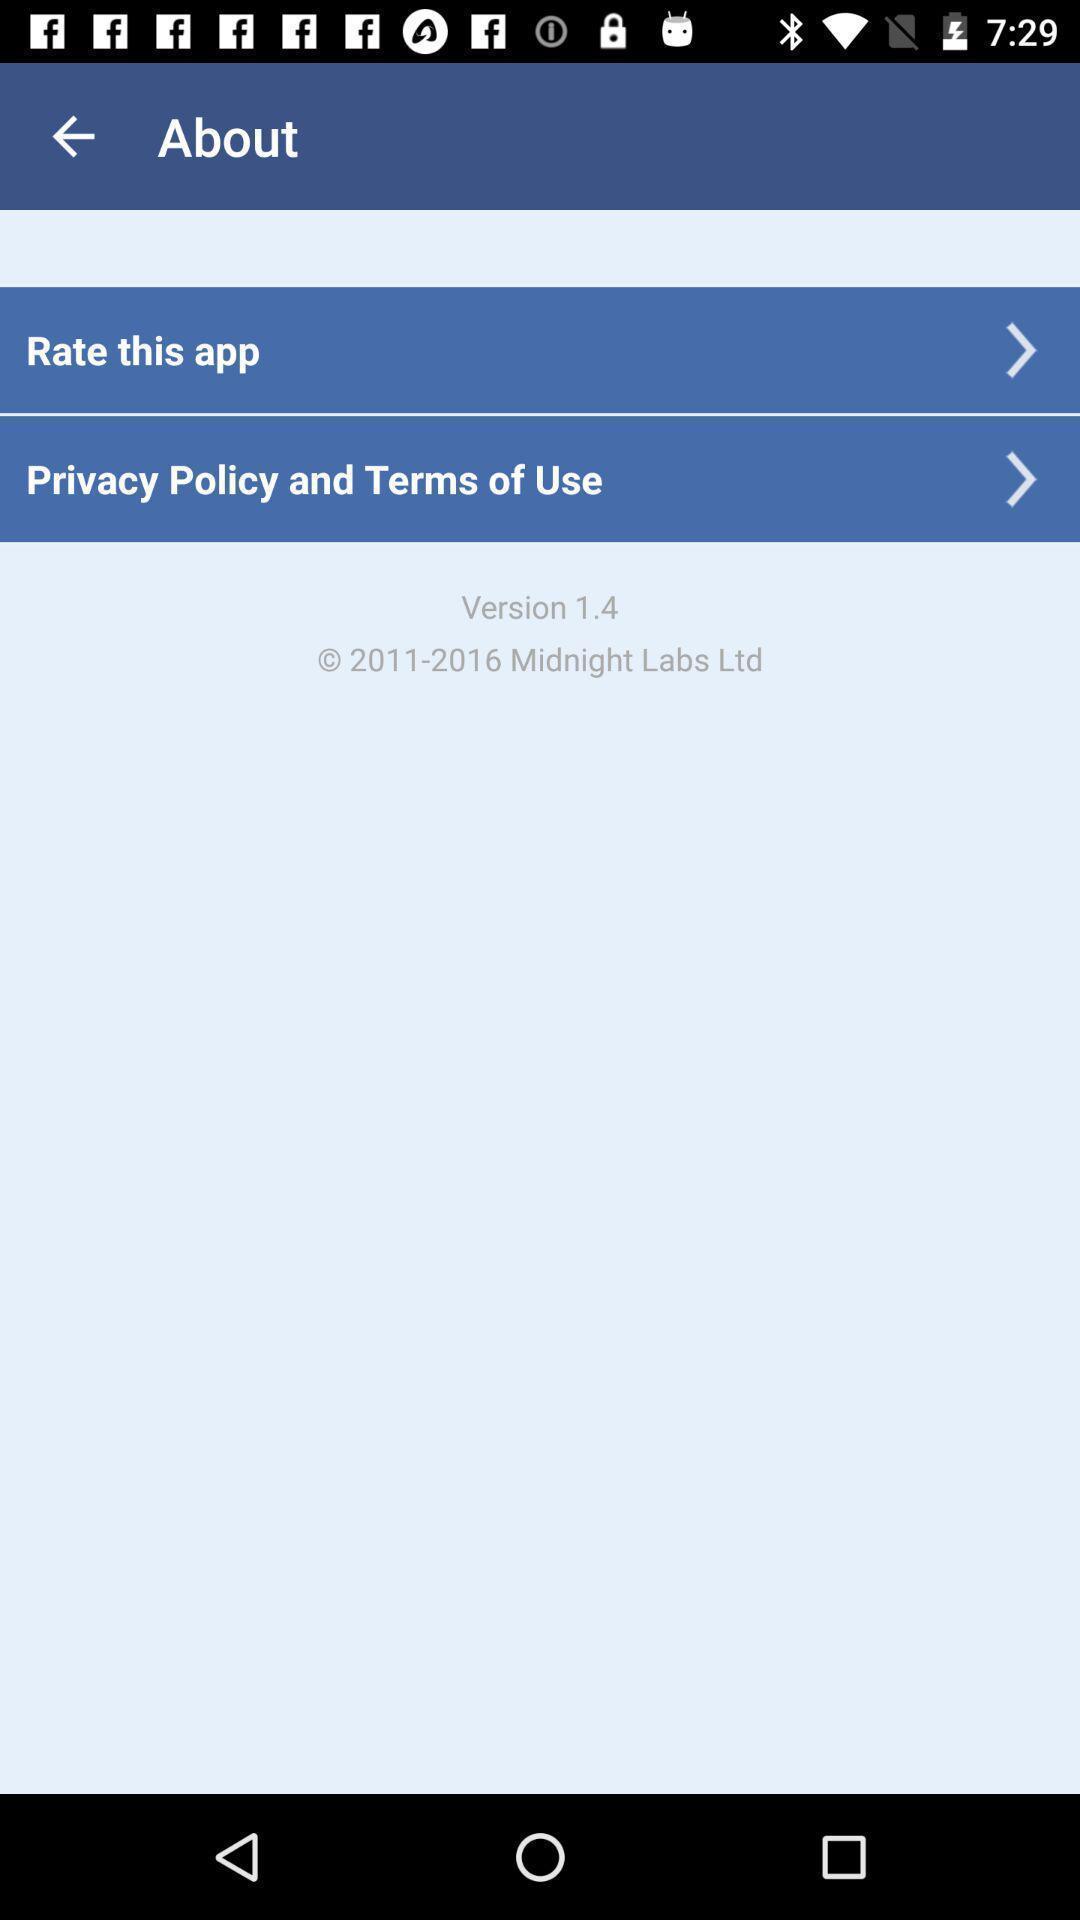Give me a summary of this screen capture. Rating page. 